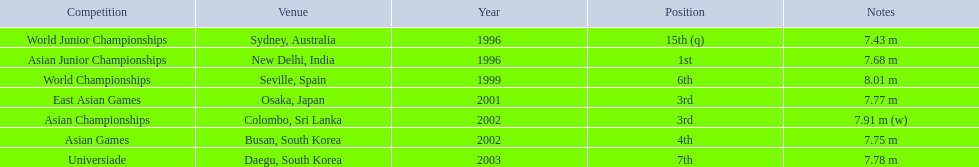What competitions did huang le compete in? World Junior Championships, Asian Junior Championships, World Championships, East Asian Games, Asian Championships, Asian Games, Universiade. What distances did he achieve in these competitions? 7.43 m, 7.68 m, 8.01 m, 7.77 m, 7.91 m (w), 7.75 m, 7.78 m. Which of these distances was the longest? 7.91 m (w). 